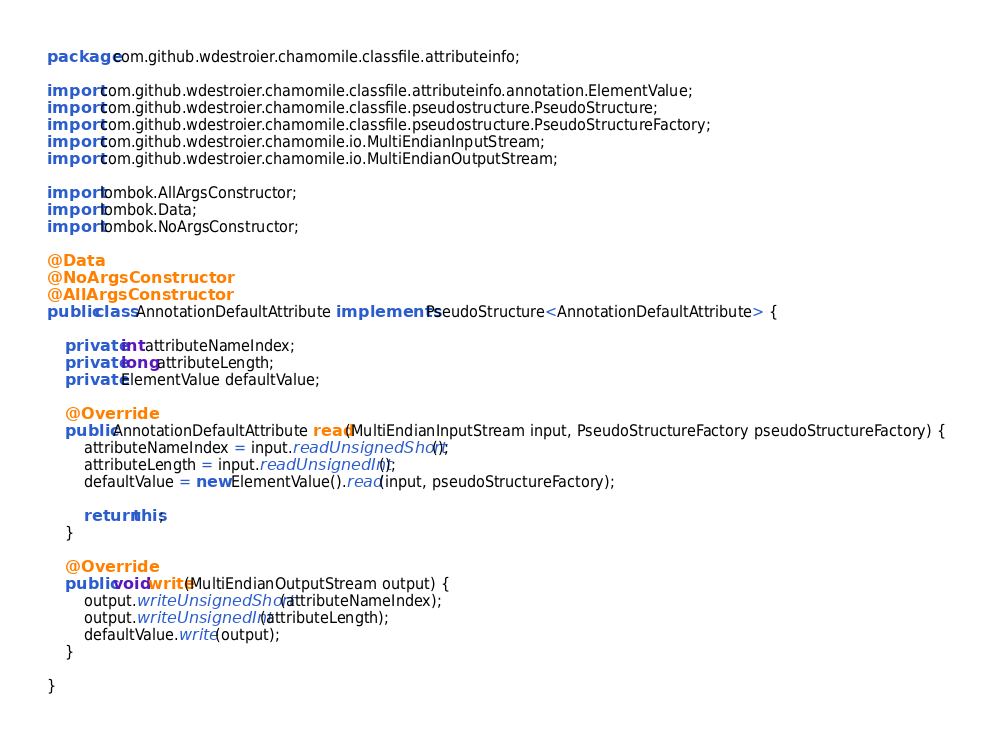<code> <loc_0><loc_0><loc_500><loc_500><_Java_>package com.github.wdestroier.chamomile.classfile.attributeinfo;

import com.github.wdestroier.chamomile.classfile.attributeinfo.annotation.ElementValue;
import com.github.wdestroier.chamomile.classfile.pseudostructure.PseudoStructure;
import com.github.wdestroier.chamomile.classfile.pseudostructure.PseudoStructureFactory;
import com.github.wdestroier.chamomile.io.MultiEndianInputStream;
import com.github.wdestroier.chamomile.io.MultiEndianOutputStream;

import lombok.AllArgsConstructor;
import lombok.Data;
import lombok.NoArgsConstructor;

@Data
@NoArgsConstructor
@AllArgsConstructor
public class AnnotationDefaultAttribute implements PseudoStructure<AnnotationDefaultAttribute> {

	private int attributeNameIndex;
	private long attributeLength;
	private ElementValue defaultValue;

	@Override
	public AnnotationDefaultAttribute read(MultiEndianInputStream input, PseudoStructureFactory pseudoStructureFactory) {
		attributeNameIndex = input.readUnsignedShort();
		attributeLength = input.readUnsignedInt();
		defaultValue = new ElementValue().read(input, pseudoStructureFactory);

		return this;
	}

	@Override
	public void write(MultiEndianOutputStream output) {
		output.writeUnsignedShort(attributeNameIndex);
		output.writeUnsignedInt(attributeLength);
		defaultValue.write(output);
	}

}
</code> 